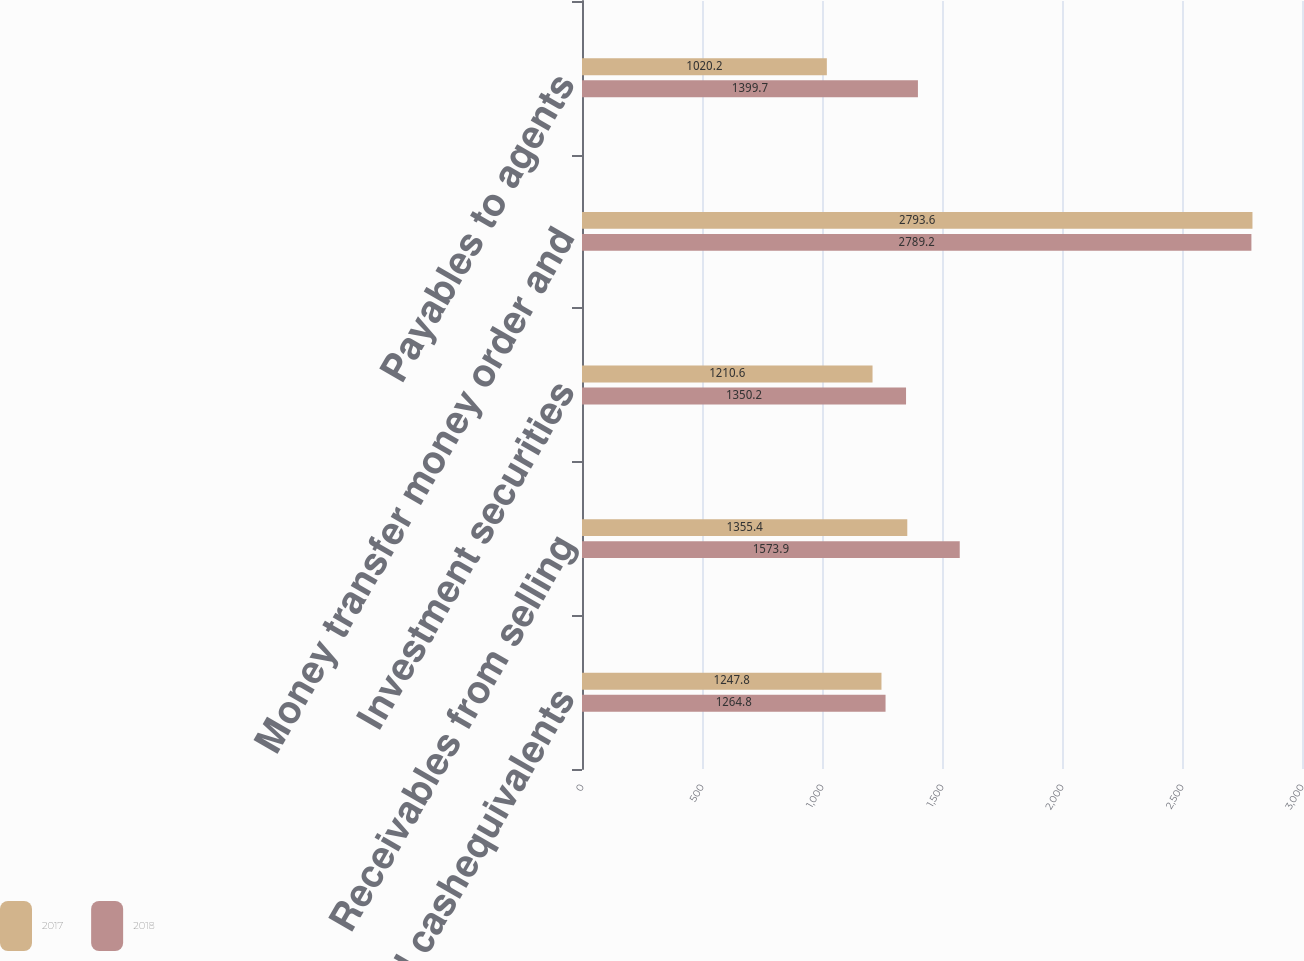Convert chart. <chart><loc_0><loc_0><loc_500><loc_500><stacked_bar_chart><ecel><fcel>Cash and cashequivalents<fcel>Receivables from selling<fcel>Investment securities<fcel>Money transfer money order and<fcel>Payables to agents<nl><fcel>2017<fcel>1247.8<fcel>1355.4<fcel>1210.6<fcel>2793.6<fcel>1020.2<nl><fcel>2018<fcel>1264.8<fcel>1573.9<fcel>1350.2<fcel>2789.2<fcel>1399.7<nl></chart> 